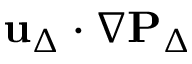Convert formula to latex. <formula><loc_0><loc_0><loc_500><loc_500>u _ { \Delta } \cdot \nabla P _ { \Delta }</formula> 